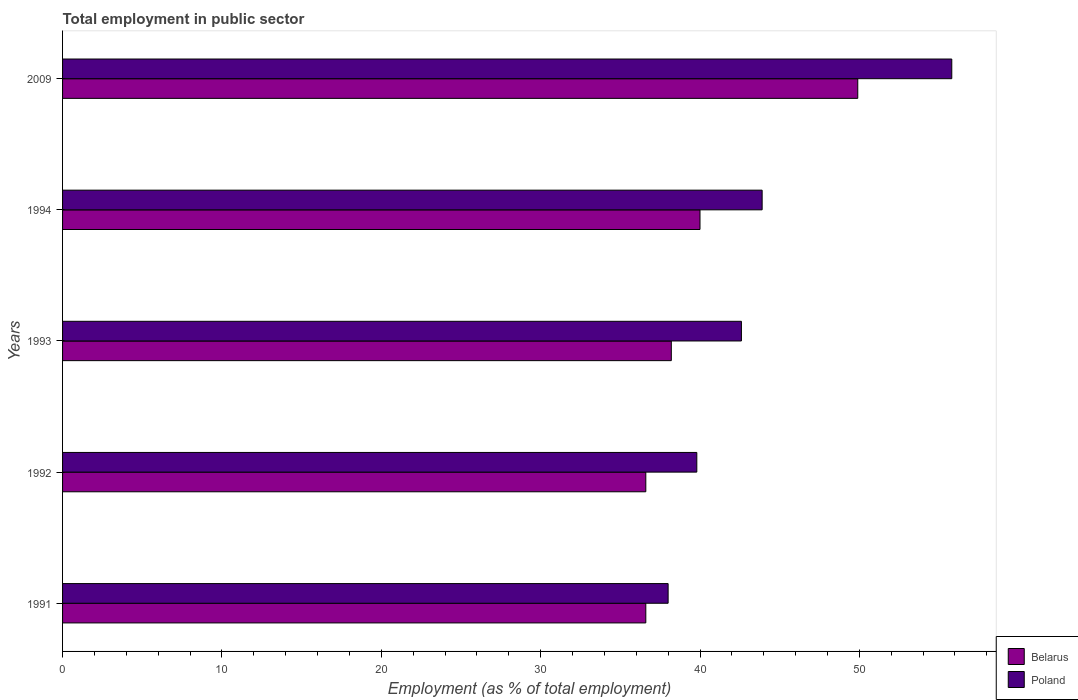How many different coloured bars are there?
Your response must be concise. 2. How many groups of bars are there?
Make the answer very short. 5. Are the number of bars per tick equal to the number of legend labels?
Keep it short and to the point. Yes. Are the number of bars on each tick of the Y-axis equal?
Keep it short and to the point. Yes. In how many cases, is the number of bars for a given year not equal to the number of legend labels?
Ensure brevity in your answer.  0. Across all years, what is the maximum employment in public sector in Belarus?
Your response must be concise. 49.9. Across all years, what is the minimum employment in public sector in Belarus?
Provide a short and direct response. 36.6. What is the total employment in public sector in Poland in the graph?
Keep it short and to the point. 220.1. What is the difference between the employment in public sector in Belarus in 1994 and that in 2009?
Provide a succinct answer. -9.9. What is the difference between the employment in public sector in Belarus in 1993 and the employment in public sector in Poland in 2009?
Ensure brevity in your answer.  -17.6. What is the average employment in public sector in Belarus per year?
Provide a succinct answer. 40.26. In the year 1991, what is the difference between the employment in public sector in Belarus and employment in public sector in Poland?
Your response must be concise. -1.4. In how many years, is the employment in public sector in Belarus greater than 28 %?
Your answer should be compact. 5. What is the ratio of the employment in public sector in Belarus in 1994 to that in 2009?
Offer a terse response. 0.8. Is the employment in public sector in Belarus in 1993 less than that in 2009?
Offer a terse response. Yes. What is the difference between the highest and the second highest employment in public sector in Poland?
Provide a short and direct response. 11.9. What is the difference between the highest and the lowest employment in public sector in Poland?
Offer a terse response. 17.8. What does the 2nd bar from the top in 1994 represents?
Your response must be concise. Belarus. What does the 1st bar from the bottom in 1994 represents?
Ensure brevity in your answer.  Belarus. Are all the bars in the graph horizontal?
Your answer should be very brief. Yes. Are the values on the major ticks of X-axis written in scientific E-notation?
Make the answer very short. No. Does the graph contain grids?
Your response must be concise. No. Where does the legend appear in the graph?
Ensure brevity in your answer.  Bottom right. How are the legend labels stacked?
Offer a very short reply. Vertical. What is the title of the graph?
Offer a very short reply. Total employment in public sector. Does "Argentina" appear as one of the legend labels in the graph?
Give a very brief answer. No. What is the label or title of the X-axis?
Give a very brief answer. Employment (as % of total employment). What is the Employment (as % of total employment) in Belarus in 1991?
Keep it short and to the point. 36.6. What is the Employment (as % of total employment) of Belarus in 1992?
Keep it short and to the point. 36.6. What is the Employment (as % of total employment) of Poland in 1992?
Offer a terse response. 39.8. What is the Employment (as % of total employment) in Belarus in 1993?
Provide a short and direct response. 38.2. What is the Employment (as % of total employment) of Poland in 1993?
Your answer should be very brief. 42.6. What is the Employment (as % of total employment) of Poland in 1994?
Give a very brief answer. 43.9. What is the Employment (as % of total employment) in Belarus in 2009?
Offer a very short reply. 49.9. What is the Employment (as % of total employment) in Poland in 2009?
Your response must be concise. 55.8. Across all years, what is the maximum Employment (as % of total employment) of Belarus?
Your answer should be very brief. 49.9. Across all years, what is the maximum Employment (as % of total employment) of Poland?
Offer a terse response. 55.8. Across all years, what is the minimum Employment (as % of total employment) in Belarus?
Your answer should be compact. 36.6. Across all years, what is the minimum Employment (as % of total employment) of Poland?
Offer a terse response. 38. What is the total Employment (as % of total employment) in Belarus in the graph?
Give a very brief answer. 201.3. What is the total Employment (as % of total employment) of Poland in the graph?
Offer a very short reply. 220.1. What is the difference between the Employment (as % of total employment) of Poland in 1991 and that in 1992?
Provide a short and direct response. -1.8. What is the difference between the Employment (as % of total employment) in Belarus in 1991 and that in 1993?
Your answer should be very brief. -1.6. What is the difference between the Employment (as % of total employment) in Belarus in 1991 and that in 1994?
Give a very brief answer. -3.4. What is the difference between the Employment (as % of total employment) in Poland in 1991 and that in 1994?
Offer a terse response. -5.9. What is the difference between the Employment (as % of total employment) of Poland in 1991 and that in 2009?
Give a very brief answer. -17.8. What is the difference between the Employment (as % of total employment) in Poland in 1992 and that in 1993?
Your answer should be very brief. -2.8. What is the difference between the Employment (as % of total employment) in Belarus in 1992 and that in 2009?
Provide a succinct answer. -13.3. What is the difference between the Employment (as % of total employment) in Poland in 1992 and that in 2009?
Make the answer very short. -16. What is the difference between the Employment (as % of total employment) of Poland in 1993 and that in 1994?
Offer a terse response. -1.3. What is the difference between the Employment (as % of total employment) in Poland in 1993 and that in 2009?
Offer a terse response. -13.2. What is the difference between the Employment (as % of total employment) in Poland in 1994 and that in 2009?
Provide a succinct answer. -11.9. What is the difference between the Employment (as % of total employment) in Belarus in 1991 and the Employment (as % of total employment) in Poland in 1992?
Offer a very short reply. -3.2. What is the difference between the Employment (as % of total employment) in Belarus in 1991 and the Employment (as % of total employment) in Poland in 1993?
Your response must be concise. -6. What is the difference between the Employment (as % of total employment) of Belarus in 1991 and the Employment (as % of total employment) of Poland in 2009?
Make the answer very short. -19.2. What is the difference between the Employment (as % of total employment) in Belarus in 1992 and the Employment (as % of total employment) in Poland in 1993?
Your answer should be compact. -6. What is the difference between the Employment (as % of total employment) of Belarus in 1992 and the Employment (as % of total employment) of Poland in 2009?
Provide a succinct answer. -19.2. What is the difference between the Employment (as % of total employment) of Belarus in 1993 and the Employment (as % of total employment) of Poland in 1994?
Provide a succinct answer. -5.7. What is the difference between the Employment (as % of total employment) in Belarus in 1993 and the Employment (as % of total employment) in Poland in 2009?
Ensure brevity in your answer.  -17.6. What is the difference between the Employment (as % of total employment) in Belarus in 1994 and the Employment (as % of total employment) in Poland in 2009?
Your response must be concise. -15.8. What is the average Employment (as % of total employment) of Belarus per year?
Keep it short and to the point. 40.26. What is the average Employment (as % of total employment) of Poland per year?
Offer a terse response. 44.02. In the year 1991, what is the difference between the Employment (as % of total employment) in Belarus and Employment (as % of total employment) in Poland?
Keep it short and to the point. -1.4. In the year 1994, what is the difference between the Employment (as % of total employment) in Belarus and Employment (as % of total employment) in Poland?
Your answer should be compact. -3.9. What is the ratio of the Employment (as % of total employment) in Poland in 1991 to that in 1992?
Make the answer very short. 0.95. What is the ratio of the Employment (as % of total employment) of Belarus in 1991 to that in 1993?
Make the answer very short. 0.96. What is the ratio of the Employment (as % of total employment) in Poland in 1991 to that in 1993?
Offer a very short reply. 0.89. What is the ratio of the Employment (as % of total employment) in Belarus in 1991 to that in 1994?
Offer a very short reply. 0.92. What is the ratio of the Employment (as % of total employment) of Poland in 1991 to that in 1994?
Keep it short and to the point. 0.87. What is the ratio of the Employment (as % of total employment) in Belarus in 1991 to that in 2009?
Offer a terse response. 0.73. What is the ratio of the Employment (as % of total employment) of Poland in 1991 to that in 2009?
Keep it short and to the point. 0.68. What is the ratio of the Employment (as % of total employment) in Belarus in 1992 to that in 1993?
Your answer should be compact. 0.96. What is the ratio of the Employment (as % of total employment) of Poland in 1992 to that in 1993?
Your response must be concise. 0.93. What is the ratio of the Employment (as % of total employment) in Belarus in 1992 to that in 1994?
Your response must be concise. 0.92. What is the ratio of the Employment (as % of total employment) in Poland in 1992 to that in 1994?
Keep it short and to the point. 0.91. What is the ratio of the Employment (as % of total employment) in Belarus in 1992 to that in 2009?
Provide a succinct answer. 0.73. What is the ratio of the Employment (as % of total employment) in Poland in 1992 to that in 2009?
Keep it short and to the point. 0.71. What is the ratio of the Employment (as % of total employment) in Belarus in 1993 to that in 1994?
Ensure brevity in your answer.  0.95. What is the ratio of the Employment (as % of total employment) in Poland in 1993 to that in 1994?
Give a very brief answer. 0.97. What is the ratio of the Employment (as % of total employment) of Belarus in 1993 to that in 2009?
Give a very brief answer. 0.77. What is the ratio of the Employment (as % of total employment) in Poland in 1993 to that in 2009?
Provide a succinct answer. 0.76. What is the ratio of the Employment (as % of total employment) of Belarus in 1994 to that in 2009?
Keep it short and to the point. 0.8. What is the ratio of the Employment (as % of total employment) in Poland in 1994 to that in 2009?
Your answer should be compact. 0.79. What is the difference between the highest and the second highest Employment (as % of total employment) of Belarus?
Ensure brevity in your answer.  9.9. 